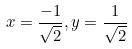Convert formula to latex. <formula><loc_0><loc_0><loc_500><loc_500>x = \frac { - 1 } { \sqrt { 2 } } , y = \frac { 1 } { \sqrt { 2 } }</formula> 